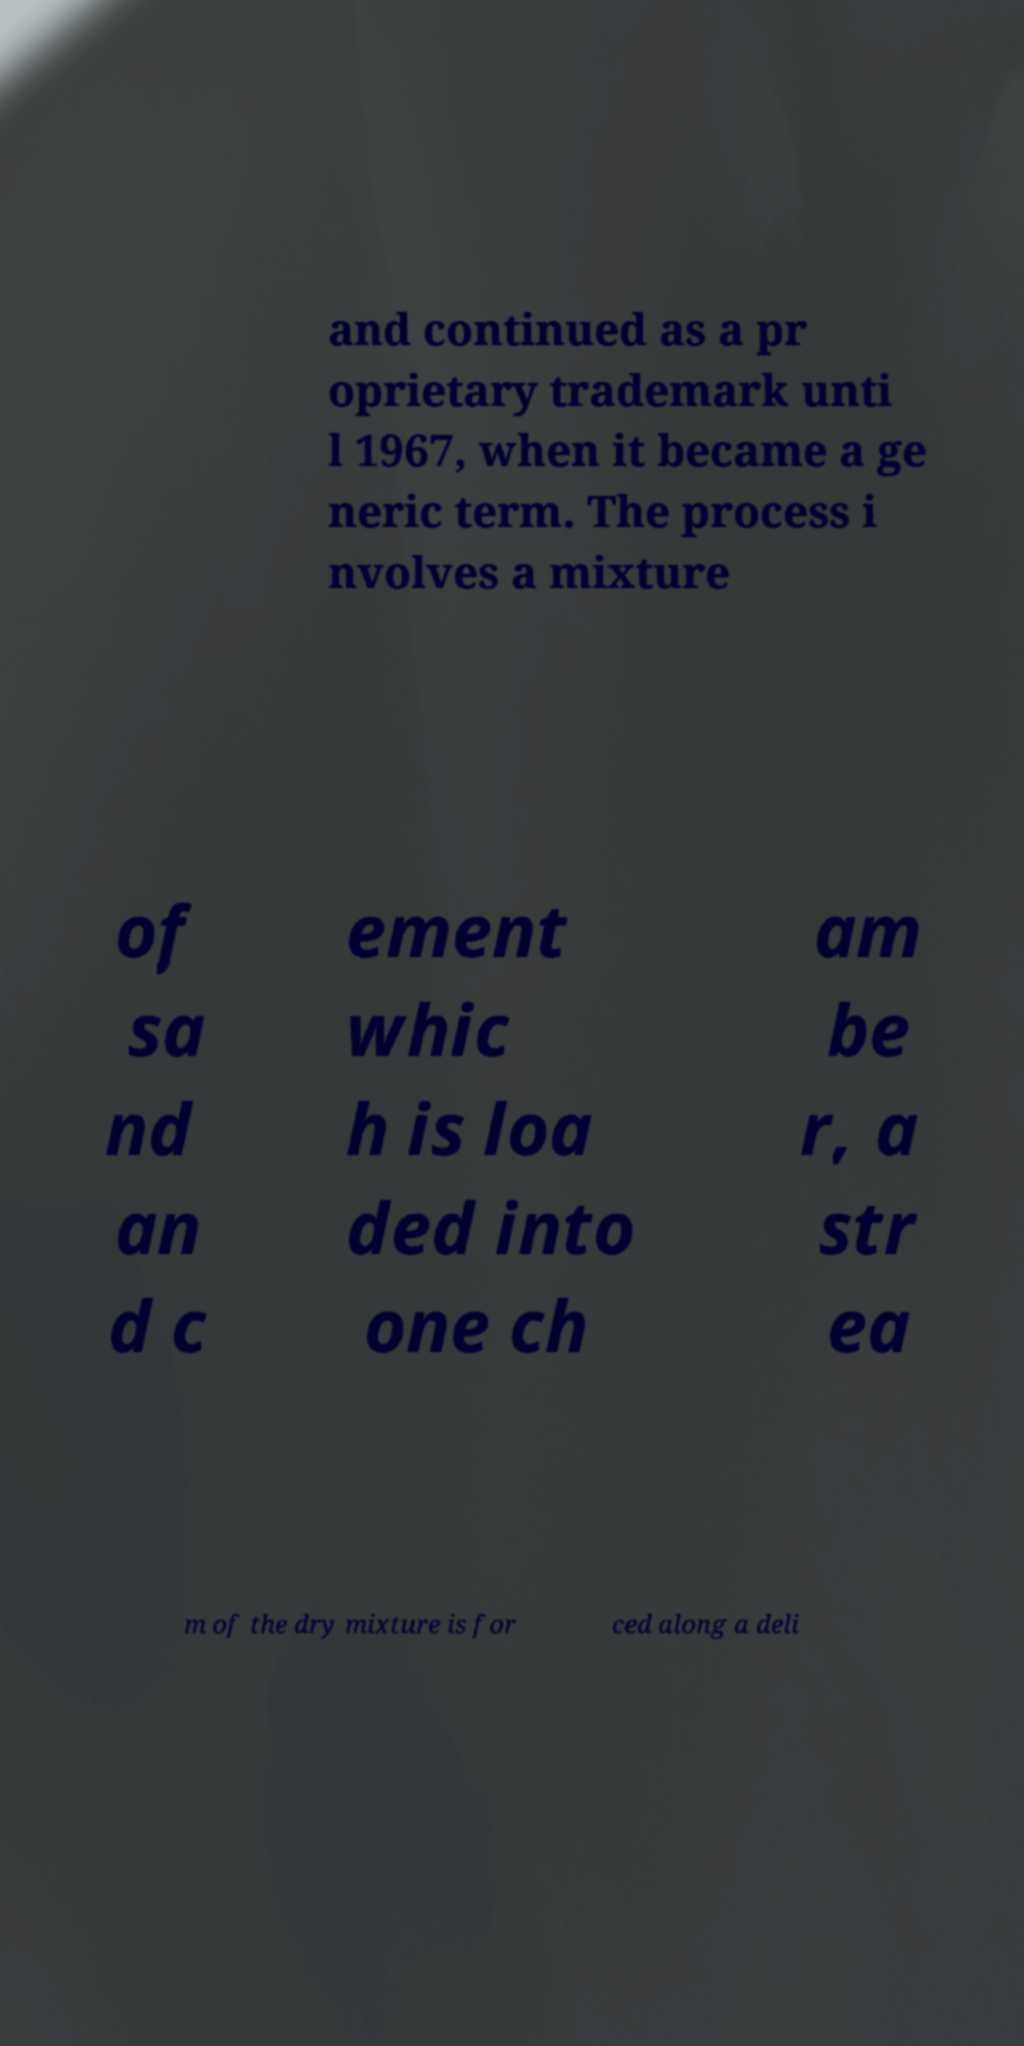I need the written content from this picture converted into text. Can you do that? and continued as a pr oprietary trademark unti l 1967, when it became a ge neric term. The process i nvolves a mixture of sa nd an d c ement whic h is loa ded into one ch am be r, a str ea m of the dry mixture is for ced along a deli 